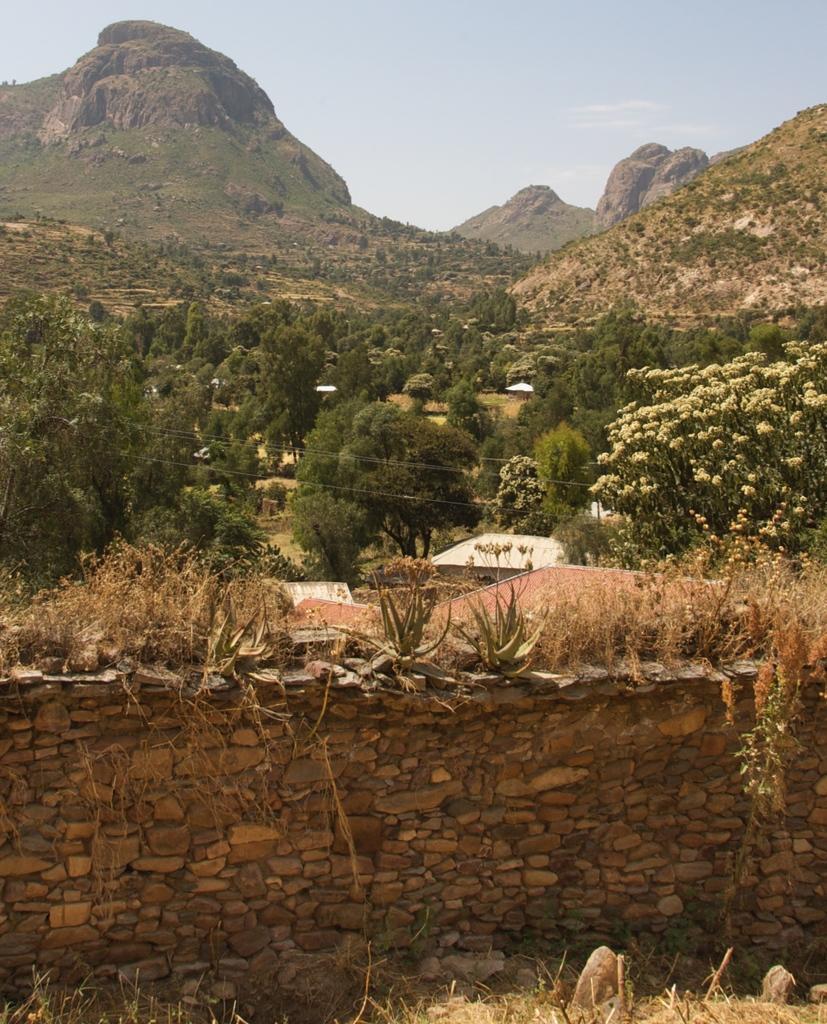Can you describe this image briefly? In this image I can see a wall, number of trees and mountain. In the background I can see sky. 